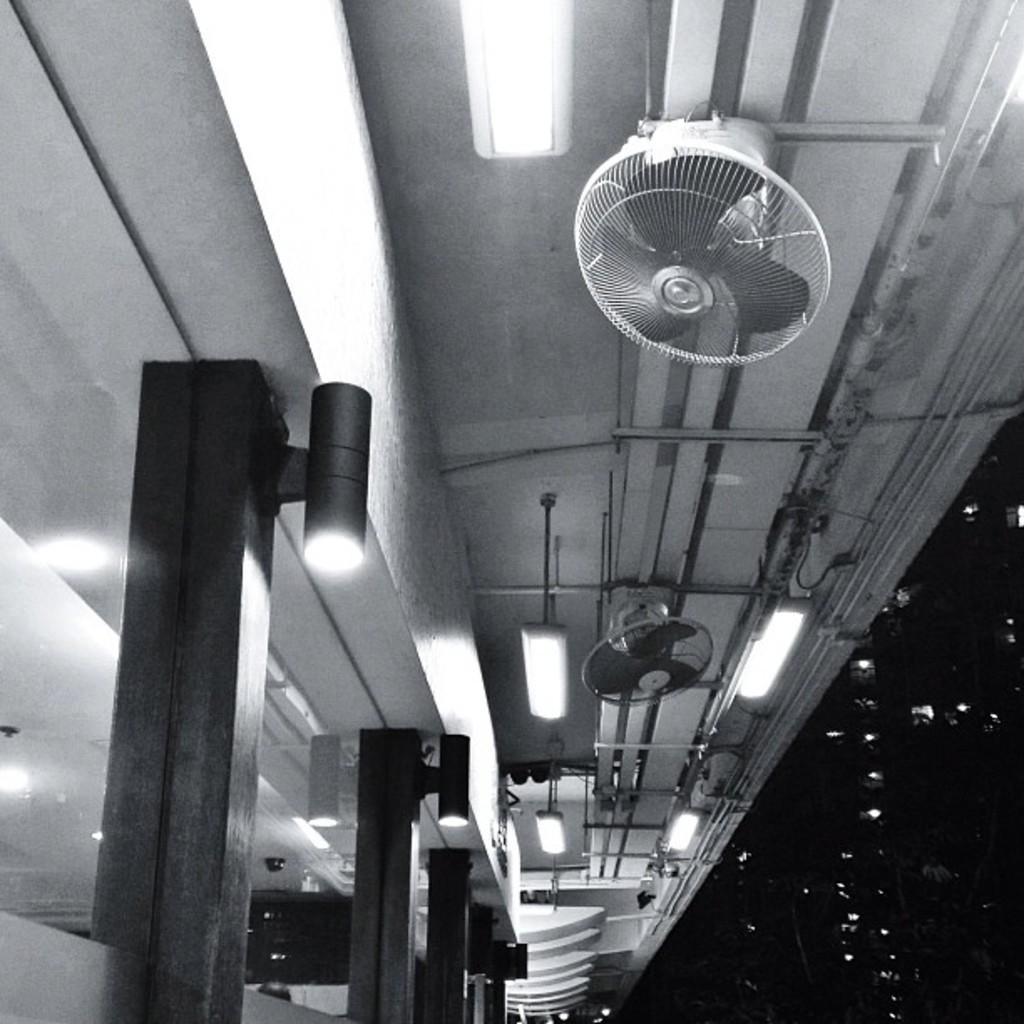Describe this image in one or two sentences. In this picture we can see fans, lights, glass and some objects and in the background it is dark. 